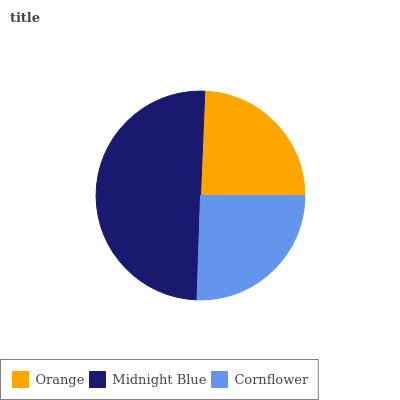Is Orange the minimum?
Answer yes or no. Yes. Is Midnight Blue the maximum?
Answer yes or no. Yes. Is Cornflower the minimum?
Answer yes or no. No. Is Cornflower the maximum?
Answer yes or no. No. Is Midnight Blue greater than Cornflower?
Answer yes or no. Yes. Is Cornflower less than Midnight Blue?
Answer yes or no. Yes. Is Cornflower greater than Midnight Blue?
Answer yes or no. No. Is Midnight Blue less than Cornflower?
Answer yes or no. No. Is Cornflower the high median?
Answer yes or no. Yes. Is Cornflower the low median?
Answer yes or no. Yes. Is Midnight Blue the high median?
Answer yes or no. No. Is Orange the low median?
Answer yes or no. No. 